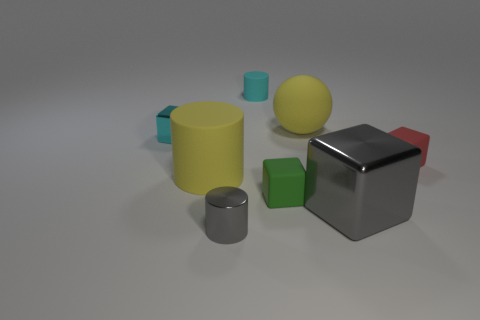Add 2 metal cylinders. How many objects exist? 10 Subtract all yellow cubes. Subtract all gray cylinders. How many cubes are left? 4 Subtract all spheres. How many objects are left? 7 Add 5 small green rubber things. How many small green rubber things are left? 6 Add 6 small red cubes. How many small red cubes exist? 7 Subtract 1 yellow spheres. How many objects are left? 7 Subtract all matte balls. Subtract all small green things. How many objects are left? 6 